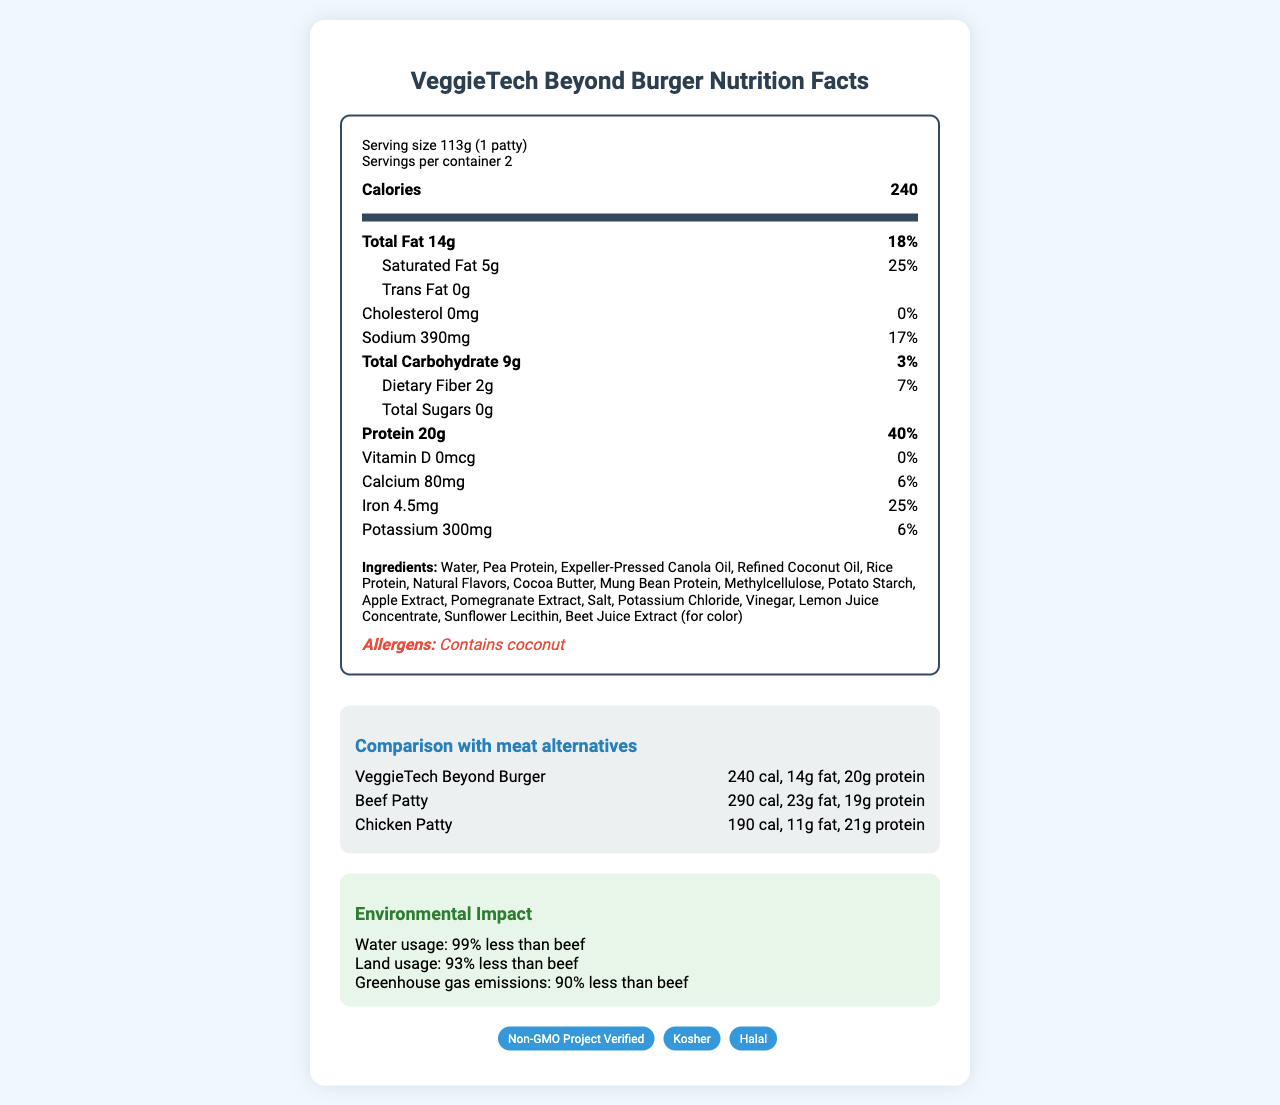what is the serving size of VeggieTech Beyond Burger? The serving size is indicated right under the product name in the nutrition facts.
Answer: 113g (1 patty) how many calories are in one serving of VeggieTech Beyond Burger? The calories per serving are listed prominently in bold in the nutrition header.
Answer: 240 how much protein does the VeggieTech Beyond Burger contain per serving? The protein content is listed under the nutrition facts section with a daily value of 40%.
Answer: 20g what is the total fat content and its daily value percentage in VeggieTech Beyond Burger? The total fat content is indicated as 14g and the daily value percentage is 18%.
Answer: 14g, 18% what are the three main ingredients of VeggieTech Beyond Burger? The ingredients are listed sequentially, with the main ingredients listed first.
Answer: Water, Pea Protein, Expeller-Pressed Canola Oil which of the following contains the most cholesterol? A. VeggieTech Beyond Burger B. Beef Patty C. Chicken Patty The beef patty contains 80mg of cholesterol, which is the highest compared to 0mg in VeggieTech Beyond Burger and 75mg in the chicken patty.
Answer: B. Beef Patty which patty has the lowest calories per serving? I. VeggieTech Beyond Burger II. Beef Patty III. Chicken Patty Chicken patty has 190 calories, which is lower compared to 240 in VeggieTech Beyond Burger and 290 in Beef Patty.
Answer: III. Chicken Patty what products are being compared in the document? A. VeggieTech Beyond Burger and Chicken Patty B. VeggieTech Beyond Burger, Beef Patty, and Chicken Patty C. VeggieTech Beyond Burger and Beef Patty D. Chicken Patty and Beef Patty The nutritional comparison section includes data for VeggieTech Beyond Burger, Beef Patty, and Chicken Patty.
Answer: B. VeggieTech Beyond Burger, Beef Patty, and Chicken Patty does the VeggieTech Beyond Burger contain trans fat? The document states that the trans fat content is 0g.
Answer: No summarize the environmental impact of VeggieTech Beyond Burger compared to beef. The eco-impact section outlines the substantial reductions in water, land, and greenhouse gas emissions compared to beef.
Answer: The VeggieTech Beyond Burger has significantly lower environmental impact than beef, including 99% less water usage, 93% less land usage, and 90% less greenhouse gas emissions. how many certifications does the VeggieTech Beyond Burger have? The document lists three certifications: Non-GMO Project Verified, Kosher, and Halal.
Answer: Three what is the sodium content and its daily value percentage in the VeggieTech Beyond Burger? The sodium content is listed as 390mg and its daily value percentage is 17%.
Answer: 390mg, 17% which product has the highest protein content per serving? The chicken patty contains 21g of protein compared to 20g in VeggieTech Beyond Burger and 19g in Beef Patty.
Answer: Chicken Patty how much dietary fiber does one serving of VeggieTech Beyond Burger provide? The dietary fiber content is listed as 2g and its daily value percentage is 7%.
Answer: 2g, 7% is the VeggieTech Beyond Burger allergen-free? The document mentions that it contains coconut, which is an allergen.
Answer: No what does the QR code in the document point to? The QR code points to the VeggieTech Beyond Burger information page as stated in the interactive features section.
Answer: https://veggietech.com/beyond-burger-info how much cholesterol is in the VeggieTech Beyond Burger? The cholesterol content is noted as 0mg with a daily value percentage of 0%.
Answer: 0mg, 0% what's the daily value percentage of iron in a VeggieTech Beyond Burger patty? The document lists iron content with a daily value percentage of 25%.
Answer: 25% how does the VeggieTech Beyond Burger compare to meat alternatives in terms of total fats? The comparative data section lists the total fat contents for each option: 14g in VeggieTech Beyond Burger, 23g in Beef Patty, and 11g in Chicken Patty.
Answer: VeggieTech Beyond Burger has 14g of total fat, which is less than the 23g in a beef patty but more than the 11g in a chicken patty. what is the daily value percentage of saturated fat in the VeggieTech Beyond Burger? The saturated fat amount is listed as 5g which equates to 25% of the daily value.
Answer: 25% what is the main idea of the document? The document comprehensively outlines the nutrition facts, environmental benefits, and various features of the VeggieTech Beyond Burger, positioning it as a healthier and environmentally friendly alternative to traditional meat patties.
Answer: The document provides detailed nutritional information and comparison data for the VeggieTech Beyond Burger, highlighting its health benefits, ingredients, allergens, eco-impact, and interactive features when compared to beef and chicken patties. 